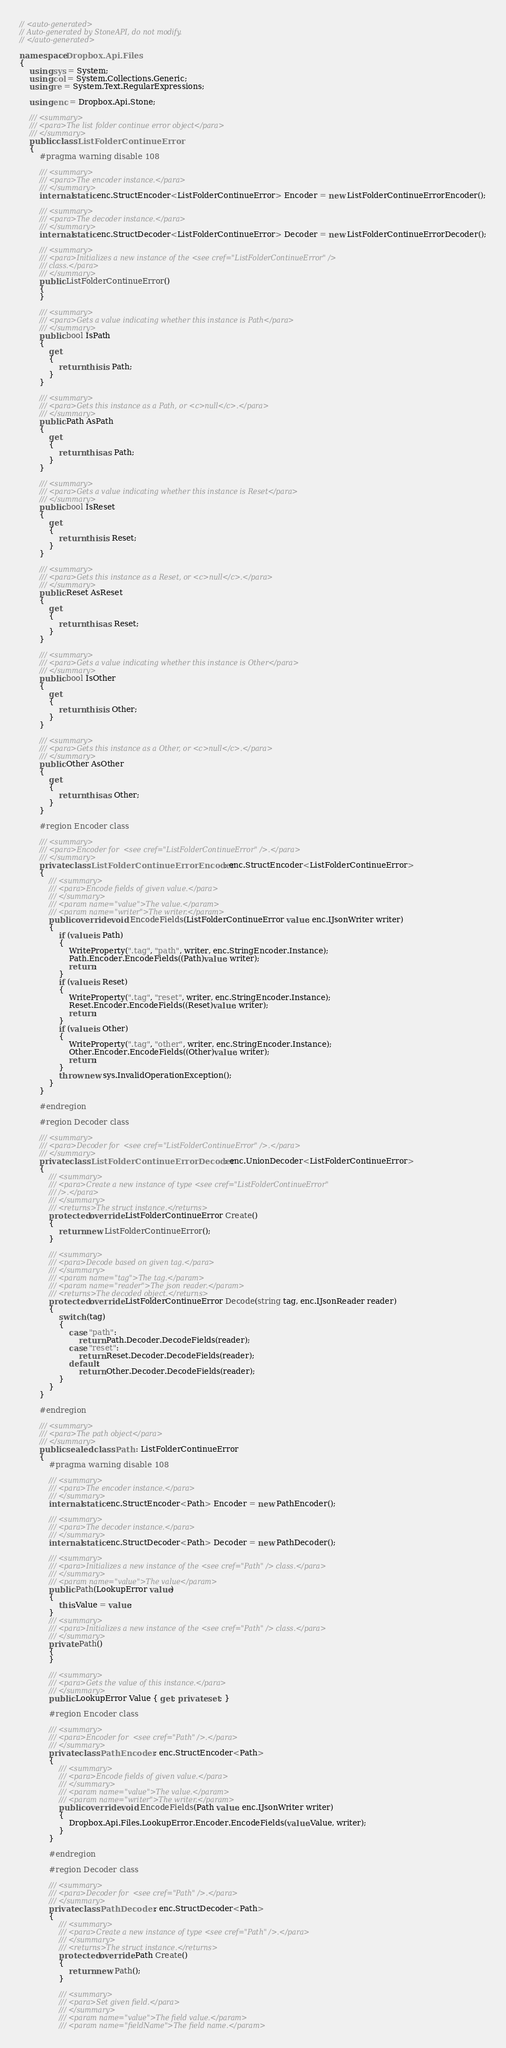<code> <loc_0><loc_0><loc_500><loc_500><_C#_>// <auto-generated>
// Auto-generated by StoneAPI, do not modify.
// </auto-generated>

namespace Dropbox.Api.Files
{
    using sys = System;
    using col = System.Collections.Generic;
    using re = System.Text.RegularExpressions;

    using enc = Dropbox.Api.Stone;

    /// <summary>
    /// <para>The list folder continue error object</para>
    /// </summary>
    public class ListFolderContinueError
    {
        #pragma warning disable 108

        /// <summary>
        /// <para>The encoder instance.</para>
        /// </summary>
        internal static enc.StructEncoder<ListFolderContinueError> Encoder = new ListFolderContinueErrorEncoder();

        /// <summary>
        /// <para>The decoder instance.</para>
        /// </summary>
        internal static enc.StructDecoder<ListFolderContinueError> Decoder = new ListFolderContinueErrorDecoder();

        /// <summary>
        /// <para>Initializes a new instance of the <see cref="ListFolderContinueError" />
        /// class.</para>
        /// </summary>
        public ListFolderContinueError()
        {
        }

        /// <summary>
        /// <para>Gets a value indicating whether this instance is Path</para>
        /// </summary>
        public bool IsPath
        {
            get
            {
                return this is Path;
            }
        }

        /// <summary>
        /// <para>Gets this instance as a Path, or <c>null</c>.</para>
        /// </summary>
        public Path AsPath
        {
            get
            {
                return this as Path;
            }
        }

        /// <summary>
        /// <para>Gets a value indicating whether this instance is Reset</para>
        /// </summary>
        public bool IsReset
        {
            get
            {
                return this is Reset;
            }
        }

        /// <summary>
        /// <para>Gets this instance as a Reset, or <c>null</c>.</para>
        /// </summary>
        public Reset AsReset
        {
            get
            {
                return this as Reset;
            }
        }

        /// <summary>
        /// <para>Gets a value indicating whether this instance is Other</para>
        /// </summary>
        public bool IsOther
        {
            get
            {
                return this is Other;
            }
        }

        /// <summary>
        /// <para>Gets this instance as a Other, or <c>null</c>.</para>
        /// </summary>
        public Other AsOther
        {
            get
            {
                return this as Other;
            }
        }

        #region Encoder class

        /// <summary>
        /// <para>Encoder for  <see cref="ListFolderContinueError" />.</para>
        /// </summary>
        private class ListFolderContinueErrorEncoder : enc.StructEncoder<ListFolderContinueError>
        {
            /// <summary>
            /// <para>Encode fields of given value.</para>
            /// </summary>
            /// <param name="value">The value.</param>
            /// <param name="writer">The writer.</param>
            public override void EncodeFields(ListFolderContinueError value, enc.IJsonWriter writer)
            {
                if (value is Path)
                {
                    WriteProperty(".tag", "path", writer, enc.StringEncoder.Instance);
                    Path.Encoder.EncodeFields((Path)value, writer);
                    return;
                }
                if (value is Reset)
                {
                    WriteProperty(".tag", "reset", writer, enc.StringEncoder.Instance);
                    Reset.Encoder.EncodeFields((Reset)value, writer);
                    return;
                }
                if (value is Other)
                {
                    WriteProperty(".tag", "other", writer, enc.StringEncoder.Instance);
                    Other.Encoder.EncodeFields((Other)value, writer);
                    return;
                }
                throw new sys.InvalidOperationException();
            }
        }

        #endregion

        #region Decoder class

        /// <summary>
        /// <para>Decoder for  <see cref="ListFolderContinueError" />.</para>
        /// </summary>
        private class ListFolderContinueErrorDecoder : enc.UnionDecoder<ListFolderContinueError>
        {
            /// <summary>
            /// <para>Create a new instance of type <see cref="ListFolderContinueError"
            /// />.</para>
            /// </summary>
            /// <returns>The struct instance.</returns>
            protected override ListFolderContinueError Create()
            {
                return new ListFolderContinueError();
            }

            /// <summary>
            /// <para>Decode based on given tag.</para>
            /// </summary>
            /// <param name="tag">The tag.</param>
            /// <param name="reader">The json reader.</param>
            /// <returns>The decoded object.</returns>
            protected override ListFolderContinueError Decode(string tag, enc.IJsonReader reader)
            {
                switch (tag)
                {
                    case "path":
                        return Path.Decoder.DecodeFields(reader);
                    case "reset":
                        return Reset.Decoder.DecodeFields(reader);
                    default:
                        return Other.Decoder.DecodeFields(reader);
                }
            }
        }

        #endregion

        /// <summary>
        /// <para>The path object</para>
        /// </summary>
        public sealed class Path : ListFolderContinueError
        {
            #pragma warning disable 108

            /// <summary>
            /// <para>The encoder instance.</para>
            /// </summary>
            internal static enc.StructEncoder<Path> Encoder = new PathEncoder();

            /// <summary>
            /// <para>The decoder instance.</para>
            /// </summary>
            internal static enc.StructDecoder<Path> Decoder = new PathDecoder();

            /// <summary>
            /// <para>Initializes a new instance of the <see cref="Path" /> class.</para>
            /// </summary>
            /// <param name="value">The value</param>
            public Path(LookupError value)
            {
                this.Value = value;
            }
            /// <summary>
            /// <para>Initializes a new instance of the <see cref="Path" /> class.</para>
            /// </summary>
            private Path()
            {
            }

            /// <summary>
            /// <para>Gets the value of this instance.</para>
            /// </summary>
            public LookupError Value { get; private set; }

            #region Encoder class

            /// <summary>
            /// <para>Encoder for  <see cref="Path" />.</para>
            /// </summary>
            private class PathEncoder : enc.StructEncoder<Path>
            {
                /// <summary>
                /// <para>Encode fields of given value.</para>
                /// </summary>
                /// <param name="value">The value.</param>
                /// <param name="writer">The writer.</param>
                public override void EncodeFields(Path value, enc.IJsonWriter writer)
                {
                    Dropbox.Api.Files.LookupError.Encoder.EncodeFields(value.Value, writer);
                }
            }

            #endregion

            #region Decoder class

            /// <summary>
            /// <para>Decoder for  <see cref="Path" />.</para>
            /// </summary>
            private class PathDecoder : enc.StructDecoder<Path>
            {
                /// <summary>
                /// <para>Create a new instance of type <see cref="Path" />.</para>
                /// </summary>
                /// <returns>The struct instance.</returns>
                protected override Path Create()
                {
                    return new Path();
                }

                /// <summary>
                /// <para>Set given field.</para>
                /// </summary>
                /// <param name="value">The field value.</param>
                /// <param name="fieldName">The field name.</param></code> 